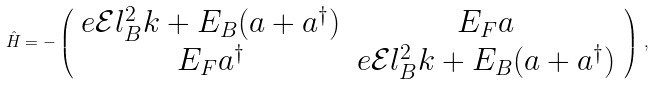<formula> <loc_0><loc_0><loc_500><loc_500>\hat { H } = - \left ( \begin{array} { c c } e \mathcal { E } l _ { B } ^ { 2 } k + E _ { B } ( a + a ^ { \dag } ) & E _ { F } a \\ E _ { F } a ^ { \dag } & e \mathcal { E } l _ { B } ^ { 2 } k + E _ { B } ( a + a ^ { \dag } ) \end{array} \right ) \, ,</formula> 